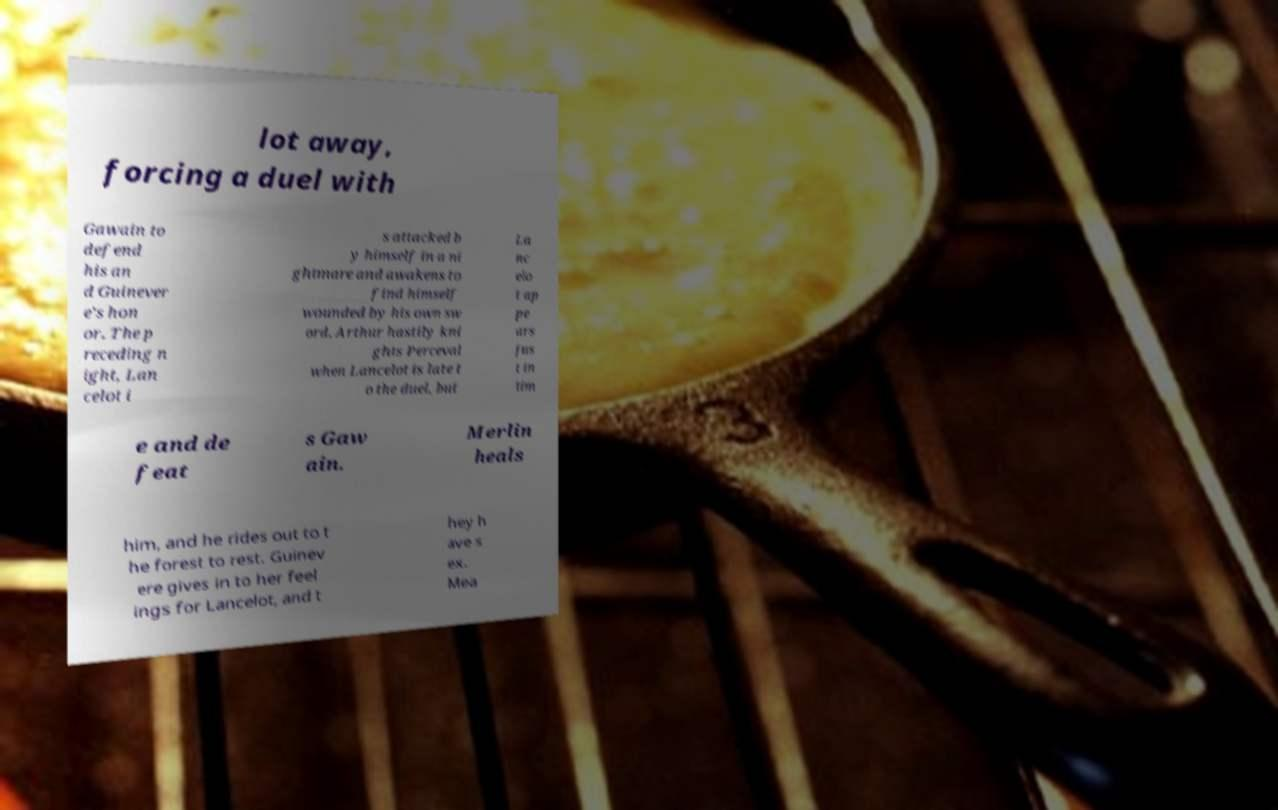Can you read and provide the text displayed in the image?This photo seems to have some interesting text. Can you extract and type it out for me? lot away, forcing a duel with Gawain to defend his an d Guinever e's hon or. The p receding n ight, Lan celot i s attacked b y himself in a ni ghtmare and awakens to find himself wounded by his own sw ord. Arthur hastily kni ghts Perceval when Lancelot is late t o the duel, but La nc elo t ap pe ars jus t in tim e and de feat s Gaw ain. Merlin heals him, and he rides out to t he forest to rest. Guinev ere gives in to her feel ings for Lancelot, and t hey h ave s ex. Mea 